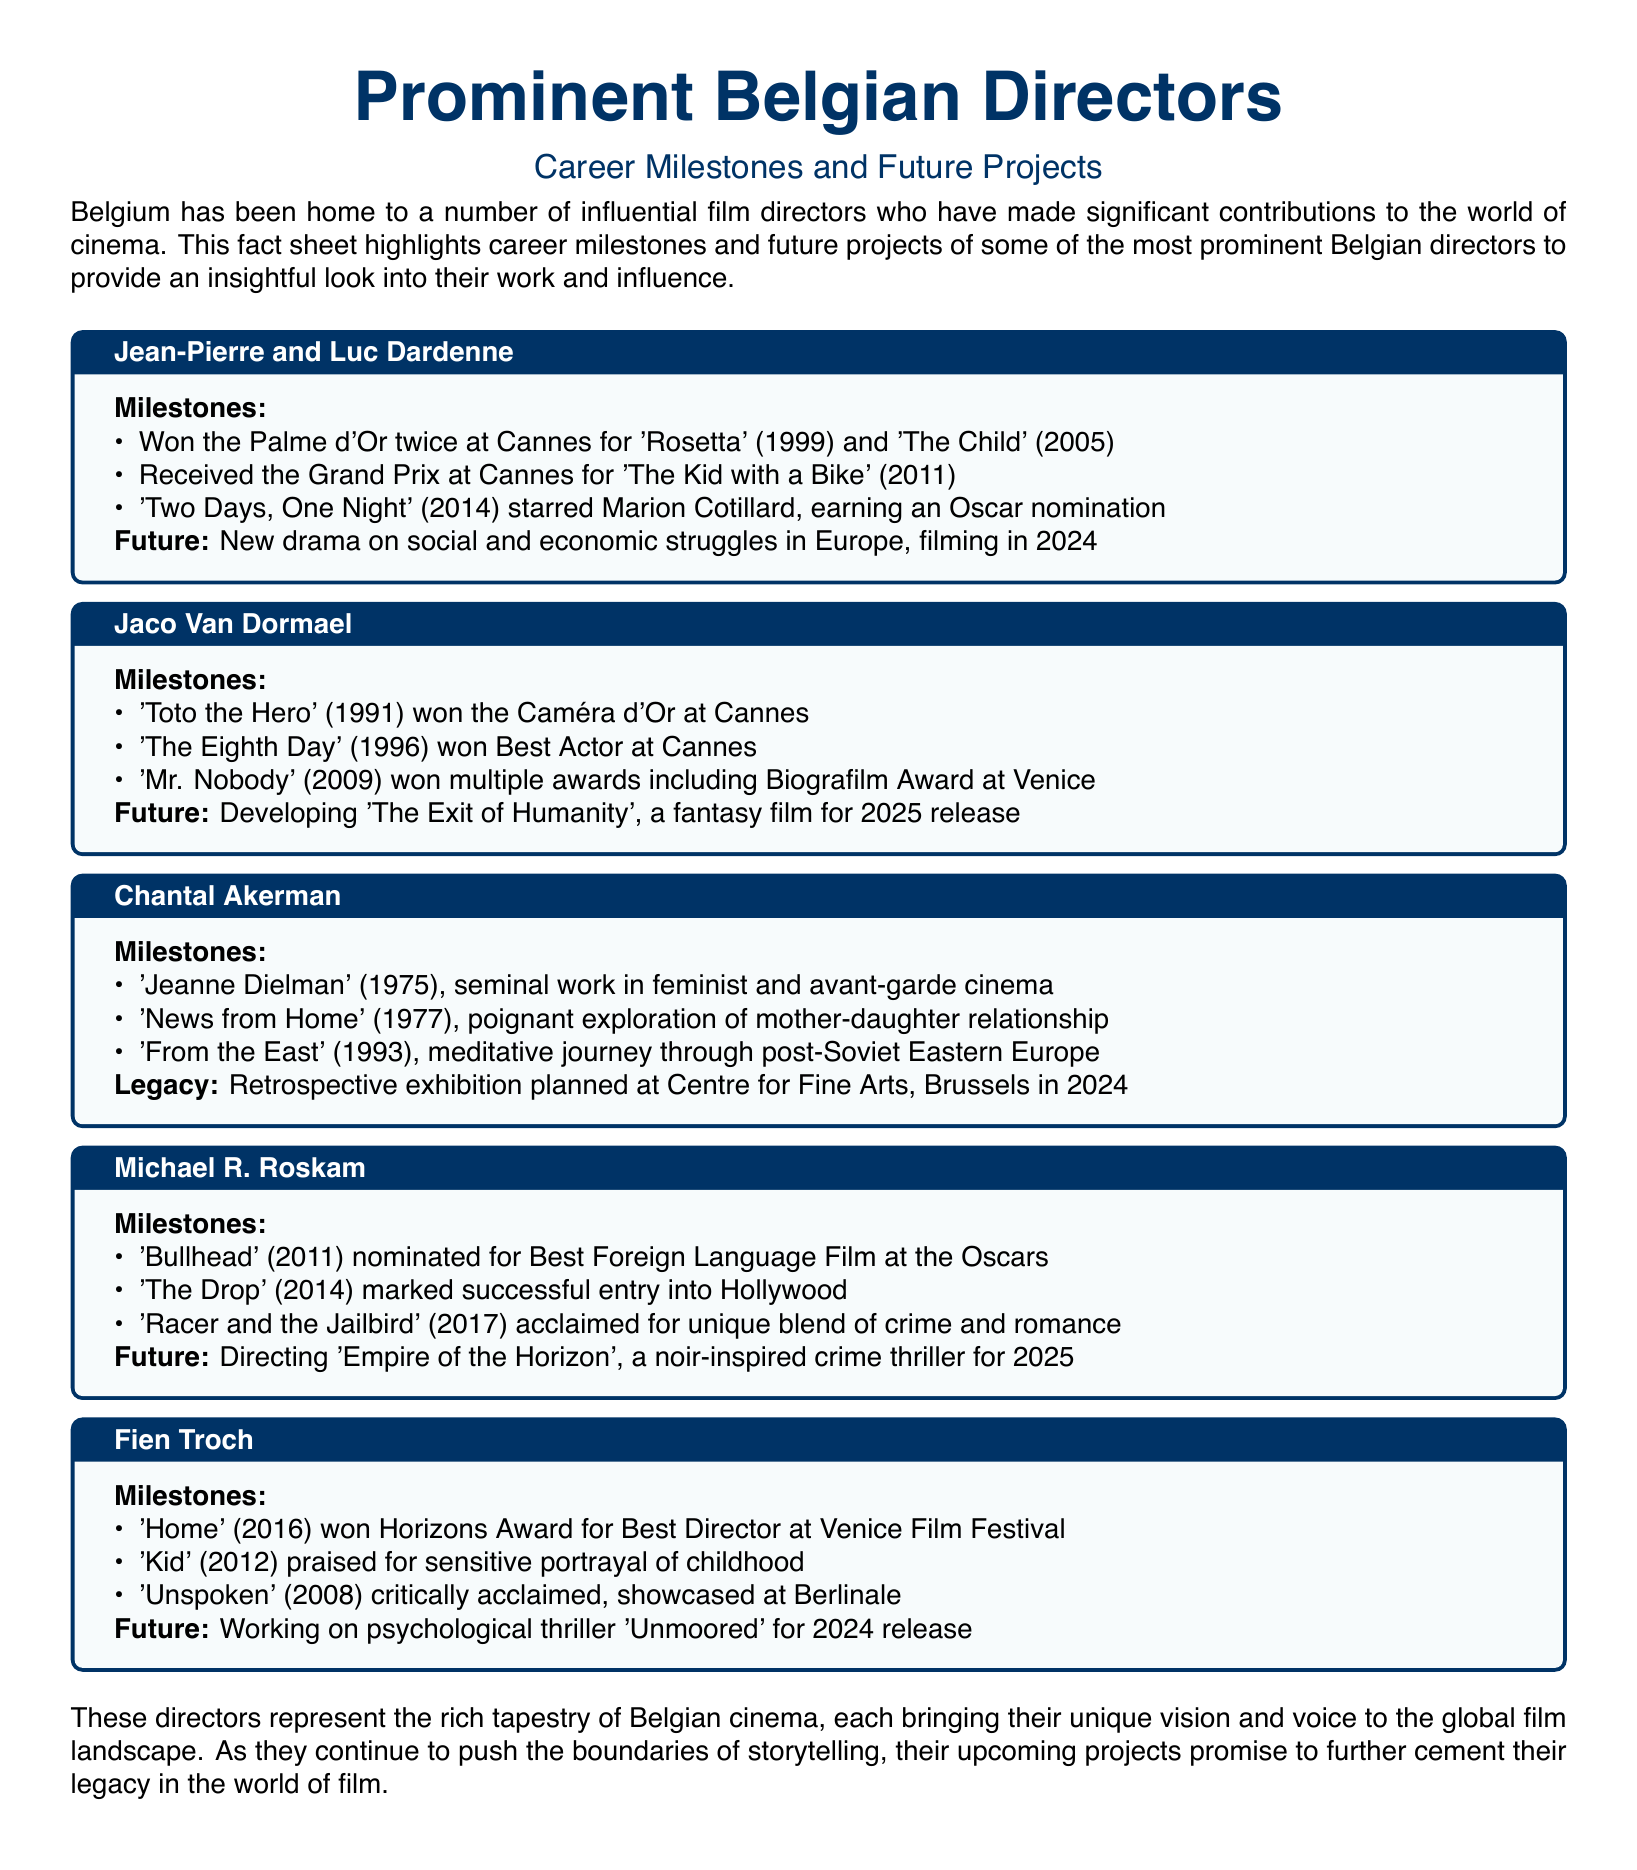What awards did Jean-Pierre and Luc Dardenne win? The document states they won the Palme d'Or twice at Cannes for 'Rosetta' and 'The Child'.
Answer: Palme d'Or What is Jaco Van Dormael developing? The fact sheet mentions he is developing 'The Exit of Humanity'.
Answer: 'The Exit of Humanity' Which film by Chantal Akerman is highlighted as a seminal work? The document emphasizes 'Jeanne Dielman' as her seminal work in feminist and avant-garde cinema.
Answer: 'Jeanne Dielman' In what year did Michael R. Roskam's film 'Bullhead' get nominated for an Oscar? The document indicates 'Bullhead' was released in 2011 and nominated for Best Foreign Language Film at the Oscars that year.
Answer: 2011 What genre is Fien Troch's upcoming film 'Unmoored'? The forthcoming project is described as a psychological thriller in the document.
Answer: psychological thriller How many times did Jean-Pierre and Luc Dardenne win the Palme d'Or? The fact sheet explicitly states they won it twice.
Answer: twice What notable award did Fien Troch win for 'Home'? The document mentions she won the Horizons Award for Best Director at the Venice Film Festival for 'Home'.
Answer: Horizons Award What is the release year for Jaco Van Dormael's fantasy film 'The Exit of Humanity'? The fact sheet indicates it is planned for release in 2025.
Answer: 2025 What is the title of Michael R. Roskam's noir-inspired crime thriller? The document clearly states the title is 'Empire of the Horizon'.
Answer: 'Empire of the Horizon' 